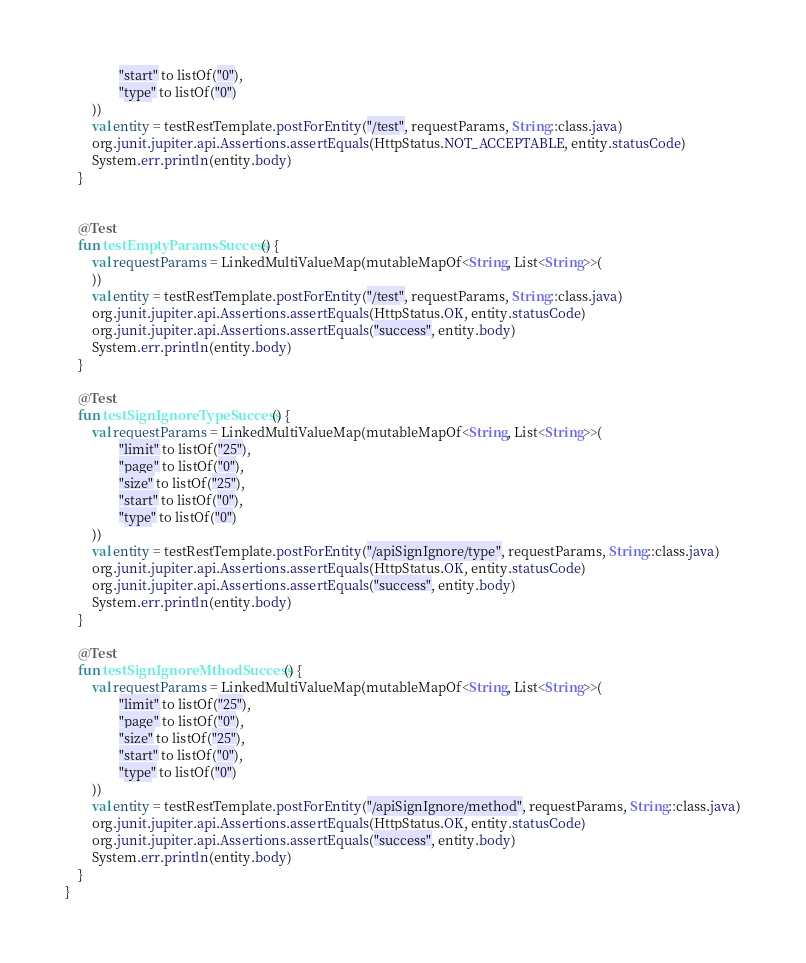Convert code to text. <code><loc_0><loc_0><loc_500><loc_500><_Kotlin_>                "start" to listOf("0"),
                "type" to listOf("0")
        ))
        val entity = testRestTemplate.postForEntity("/test", requestParams, String::class.java)
        org.junit.jupiter.api.Assertions.assertEquals(HttpStatus.NOT_ACCEPTABLE, entity.statusCode)
        System.err.println(entity.body)
    }


    @Test
    fun testEmptyParamsSuccess() {
        val requestParams = LinkedMultiValueMap(mutableMapOf<String, List<String>>(
        ))
        val entity = testRestTemplate.postForEntity("/test", requestParams, String::class.java)
        org.junit.jupiter.api.Assertions.assertEquals(HttpStatus.OK, entity.statusCode)
        org.junit.jupiter.api.Assertions.assertEquals("success", entity.body)
        System.err.println(entity.body)
    }

    @Test
    fun testSignIgnoreTypeSuccess() {
        val requestParams = LinkedMultiValueMap(mutableMapOf<String, List<String>>(
                "limit" to listOf("25"),
                "page" to listOf("0"),
                "size" to listOf("25"),
                "start" to listOf("0"),
                "type" to listOf("0")
        ))
        val entity = testRestTemplate.postForEntity("/apiSignIgnore/type", requestParams, String::class.java)
        org.junit.jupiter.api.Assertions.assertEquals(HttpStatus.OK, entity.statusCode)
        org.junit.jupiter.api.Assertions.assertEquals("success", entity.body)
        System.err.println(entity.body)
    }

    @Test
    fun testSignIgnoreMthodSuccess() {
        val requestParams = LinkedMultiValueMap(mutableMapOf<String, List<String>>(
                "limit" to listOf("25"),
                "page" to listOf("0"),
                "size" to listOf("25"),
                "start" to listOf("0"),
                "type" to listOf("0")
        ))
        val entity = testRestTemplate.postForEntity("/apiSignIgnore/method", requestParams, String::class.java)
        org.junit.jupiter.api.Assertions.assertEquals(HttpStatus.OK, entity.statusCode)
        org.junit.jupiter.api.Assertions.assertEquals("success", entity.body)
        System.err.println(entity.body)
    }
}
</code> 